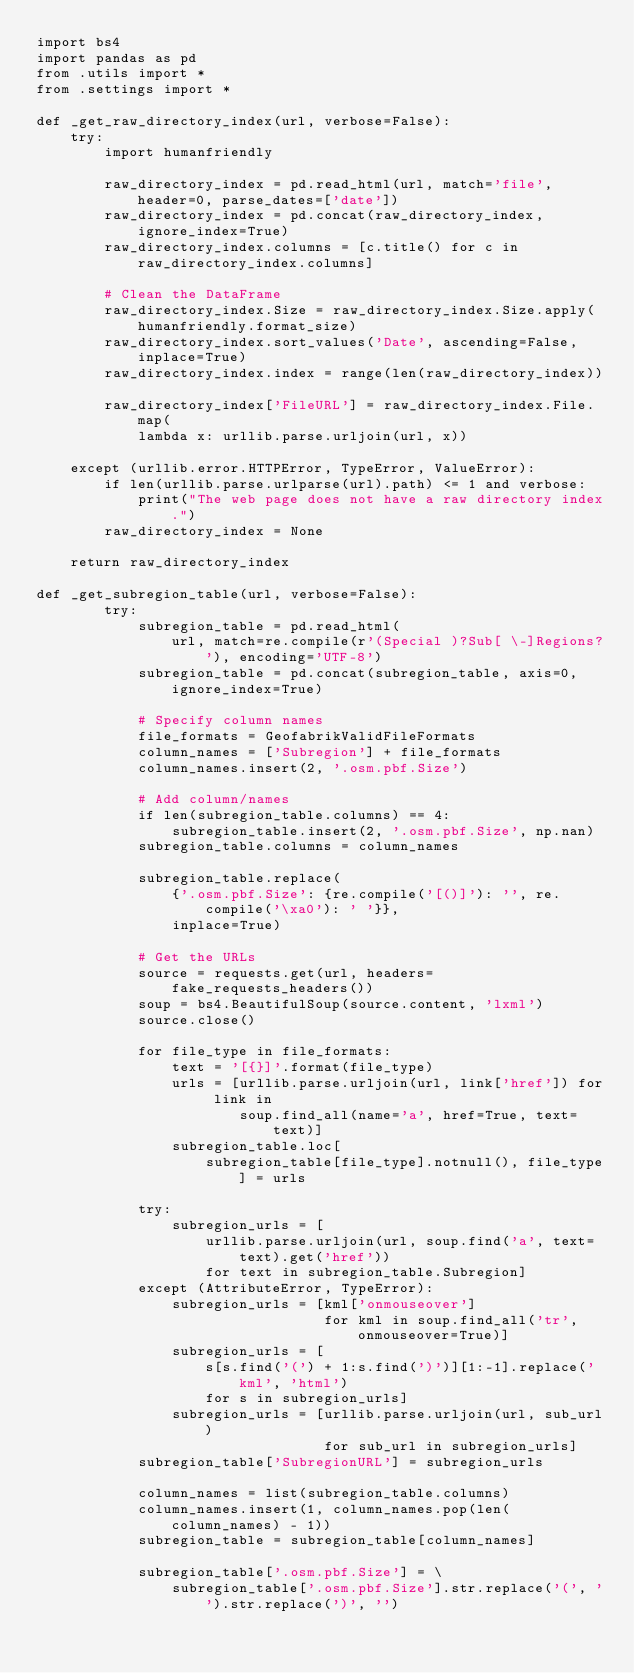Convert code to text. <code><loc_0><loc_0><loc_500><loc_500><_Python_>import bs4
import pandas as pd
from .utils import *
from .settings import *

def _get_raw_directory_index(url, verbose=False):
    try:
        import humanfriendly

        raw_directory_index = pd.read_html(url, match='file', header=0, parse_dates=['date'])
        raw_directory_index = pd.concat(raw_directory_index, ignore_index=True)
        raw_directory_index.columns = [c.title() for c in raw_directory_index.columns]

        # Clean the DataFrame
        raw_directory_index.Size = raw_directory_index.Size.apply(humanfriendly.format_size)
        raw_directory_index.sort_values('Date', ascending=False, inplace=True)
        raw_directory_index.index = range(len(raw_directory_index))

        raw_directory_index['FileURL'] = raw_directory_index.File.map(
            lambda x: urllib.parse.urljoin(url, x))

    except (urllib.error.HTTPError, TypeError, ValueError):
        if len(urllib.parse.urlparse(url).path) <= 1 and verbose:
            print("The web page does not have a raw directory index.")
        raw_directory_index = None

    return raw_directory_index

def _get_subregion_table(url, verbose=False):
        try:
            subregion_table = pd.read_html(
                url, match=re.compile(r'(Special )?Sub[ \-]Regions?'), encoding='UTF-8')
            subregion_table = pd.concat(subregion_table, axis=0, ignore_index=True)

            # Specify column names
            file_formats = GeofabrikValidFileFormats
            column_names = ['Subregion'] + file_formats
            column_names.insert(2, '.osm.pbf.Size')

            # Add column/names
            if len(subregion_table.columns) == 4:
                subregion_table.insert(2, '.osm.pbf.Size', np.nan)
            subregion_table.columns = column_names

            subregion_table.replace(
                {'.osm.pbf.Size': {re.compile('[()]'): '', re.compile('\xa0'): ' '}},
                inplace=True)

            # Get the URLs
            source = requests.get(url, headers=fake_requests_headers())
            soup = bs4.BeautifulSoup(source.content, 'lxml')
            source.close()

            for file_type in file_formats:
                text = '[{}]'.format(file_type)
                urls = [urllib.parse.urljoin(url, link['href']) for link in
                        soup.find_all(name='a', href=True, text=text)]
                subregion_table.loc[
                    subregion_table[file_type].notnull(), file_type] = urls

            try:
                subregion_urls = [
                    urllib.parse.urljoin(url, soup.find('a', text=text).get('href'))
                    for text in subregion_table.Subregion]
            except (AttributeError, TypeError):
                subregion_urls = [kml['onmouseover']
                                  for kml in soup.find_all('tr', onmouseover=True)]
                subregion_urls = [
                    s[s.find('(') + 1:s.find(')')][1:-1].replace('kml', 'html')
                    for s in subregion_urls]
                subregion_urls = [urllib.parse.urljoin(url, sub_url)
                                  for sub_url in subregion_urls]
            subregion_table['SubregionURL'] = subregion_urls

            column_names = list(subregion_table.columns)
            column_names.insert(1, column_names.pop(len(column_names) - 1))
            subregion_table = subregion_table[column_names]

            subregion_table['.osm.pbf.Size'] = \
                subregion_table['.osm.pbf.Size'].str.replace('(', '').str.replace(')', '')
</code> 